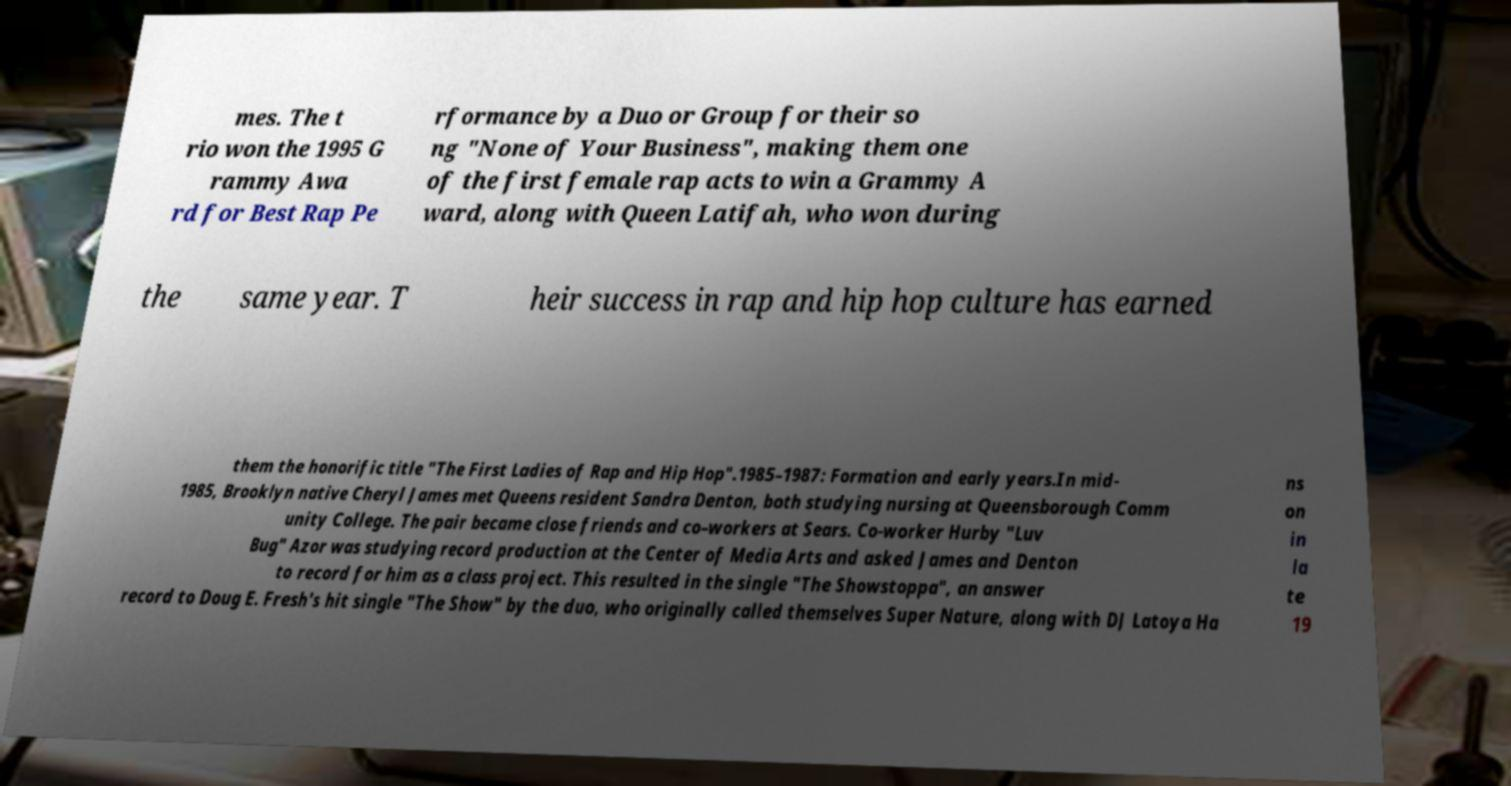What messages or text are displayed in this image? I need them in a readable, typed format. mes. The t rio won the 1995 G rammy Awa rd for Best Rap Pe rformance by a Duo or Group for their so ng "None of Your Business", making them one of the first female rap acts to win a Grammy A ward, along with Queen Latifah, who won during the same year. T heir success in rap and hip hop culture has earned them the honorific title "The First Ladies of Rap and Hip Hop".1985–1987: Formation and early years.In mid- 1985, Brooklyn native Cheryl James met Queens resident Sandra Denton, both studying nursing at Queensborough Comm unity College. The pair became close friends and co–workers at Sears. Co-worker Hurby "Luv Bug" Azor was studying record production at the Center of Media Arts and asked James and Denton to record for him as a class project. This resulted in the single "The Showstoppa", an answer record to Doug E. Fresh's hit single "The Show" by the duo, who originally called themselves Super Nature, along with DJ Latoya Ha ns on in la te 19 